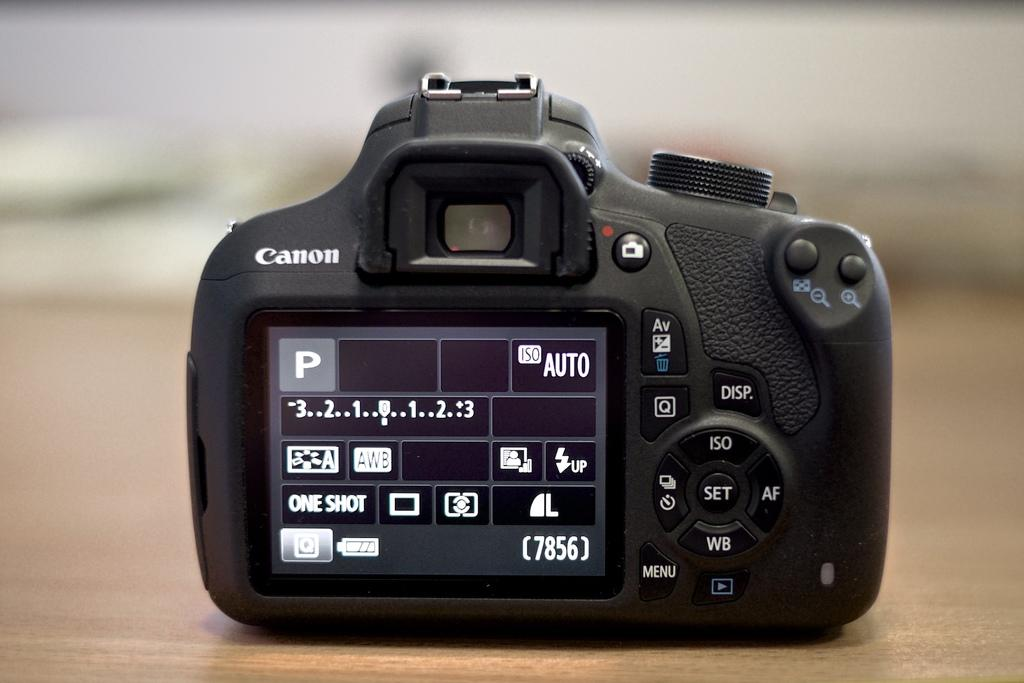What object is the main subject of the image? There is a camera in the image. What features can be seen on the camera? The camera has a screen and buttons. Is there any text or writing on the camera? Yes, there is something written on the camera. How would you describe the background of the image? The background of the image is blurred. What type of woodworking tool is being used by the carpenter in the image? There is no carpenter or woodworking tool present in the image; it features a camera with a screen, buttons, and writing. How many knots can be seen in the tree depicted in the image? There is no tree depicted in the image; it features a camera with a blurred background. 